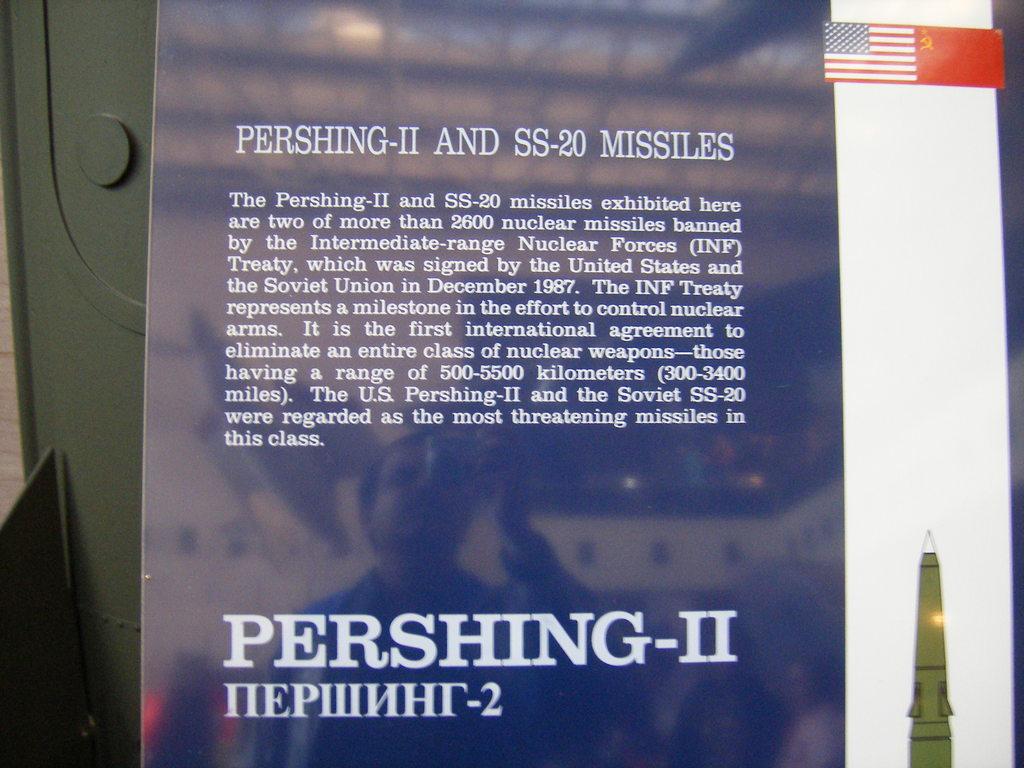How many nuclear missiles did the inf treaty ban?
Offer a very short reply. 2600. What two types of missiles are mentioned?
Your response must be concise. Pershing-ii and ss-20. 